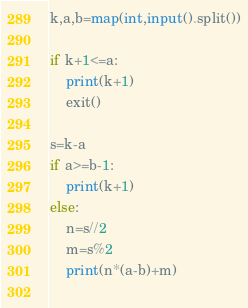Convert code to text. <code><loc_0><loc_0><loc_500><loc_500><_Python_>k,a,b=map(int,input().split())

if k+1<=a:
    print(k+1)
    exit()

s=k-a
if a>=b-1:
    print(k+1)
else:
    n=s//2
    m=s%2
    print(n*(a-b)+m)
    </code> 